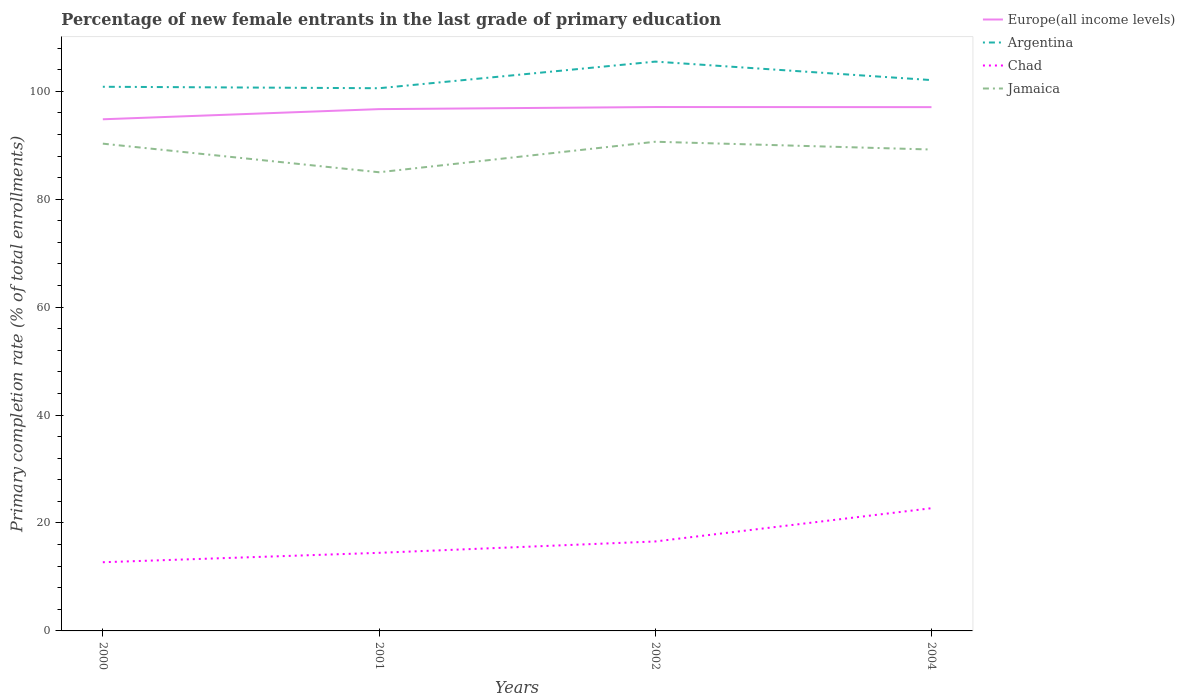How many different coloured lines are there?
Provide a short and direct response. 4. Across all years, what is the maximum percentage of new female entrants in Chad?
Your response must be concise. 12.73. In which year was the percentage of new female entrants in Europe(all income levels) maximum?
Offer a terse response. 2000. What is the total percentage of new female entrants in Argentina in the graph?
Your response must be concise. -1.51. What is the difference between the highest and the second highest percentage of new female entrants in Chad?
Give a very brief answer. 10.01. Is the percentage of new female entrants in Jamaica strictly greater than the percentage of new female entrants in Europe(all income levels) over the years?
Offer a very short reply. Yes. How many lines are there?
Provide a succinct answer. 4. What is the difference between two consecutive major ticks on the Y-axis?
Ensure brevity in your answer.  20. Are the values on the major ticks of Y-axis written in scientific E-notation?
Keep it short and to the point. No. What is the title of the graph?
Your answer should be compact. Percentage of new female entrants in the last grade of primary education. Does "Slovenia" appear as one of the legend labels in the graph?
Your response must be concise. No. What is the label or title of the Y-axis?
Give a very brief answer. Primary completion rate (% of total enrollments). What is the Primary completion rate (% of total enrollments) of Europe(all income levels) in 2000?
Provide a succinct answer. 94.81. What is the Primary completion rate (% of total enrollments) in Argentina in 2000?
Ensure brevity in your answer.  100.84. What is the Primary completion rate (% of total enrollments) in Chad in 2000?
Provide a succinct answer. 12.73. What is the Primary completion rate (% of total enrollments) of Jamaica in 2000?
Your answer should be very brief. 90.29. What is the Primary completion rate (% of total enrollments) in Europe(all income levels) in 2001?
Your answer should be very brief. 96.69. What is the Primary completion rate (% of total enrollments) in Argentina in 2001?
Provide a short and direct response. 100.56. What is the Primary completion rate (% of total enrollments) in Chad in 2001?
Your response must be concise. 14.47. What is the Primary completion rate (% of total enrollments) in Jamaica in 2001?
Offer a very short reply. 84.99. What is the Primary completion rate (% of total enrollments) of Europe(all income levels) in 2002?
Provide a succinct answer. 97.08. What is the Primary completion rate (% of total enrollments) in Argentina in 2002?
Provide a succinct answer. 105.5. What is the Primary completion rate (% of total enrollments) of Chad in 2002?
Your answer should be compact. 16.58. What is the Primary completion rate (% of total enrollments) in Jamaica in 2002?
Keep it short and to the point. 90.65. What is the Primary completion rate (% of total enrollments) of Europe(all income levels) in 2004?
Offer a terse response. 97.06. What is the Primary completion rate (% of total enrollments) of Argentina in 2004?
Keep it short and to the point. 102.07. What is the Primary completion rate (% of total enrollments) of Chad in 2004?
Make the answer very short. 22.74. What is the Primary completion rate (% of total enrollments) of Jamaica in 2004?
Ensure brevity in your answer.  89.21. Across all years, what is the maximum Primary completion rate (% of total enrollments) of Europe(all income levels)?
Keep it short and to the point. 97.08. Across all years, what is the maximum Primary completion rate (% of total enrollments) in Argentina?
Ensure brevity in your answer.  105.5. Across all years, what is the maximum Primary completion rate (% of total enrollments) in Chad?
Make the answer very short. 22.74. Across all years, what is the maximum Primary completion rate (% of total enrollments) in Jamaica?
Give a very brief answer. 90.65. Across all years, what is the minimum Primary completion rate (% of total enrollments) of Europe(all income levels)?
Offer a terse response. 94.81. Across all years, what is the minimum Primary completion rate (% of total enrollments) of Argentina?
Make the answer very short. 100.56. Across all years, what is the minimum Primary completion rate (% of total enrollments) in Chad?
Offer a terse response. 12.73. Across all years, what is the minimum Primary completion rate (% of total enrollments) in Jamaica?
Your response must be concise. 84.99. What is the total Primary completion rate (% of total enrollments) of Europe(all income levels) in the graph?
Your answer should be compact. 385.64. What is the total Primary completion rate (% of total enrollments) of Argentina in the graph?
Keep it short and to the point. 408.97. What is the total Primary completion rate (% of total enrollments) of Chad in the graph?
Provide a succinct answer. 66.52. What is the total Primary completion rate (% of total enrollments) in Jamaica in the graph?
Your answer should be compact. 355.14. What is the difference between the Primary completion rate (% of total enrollments) of Europe(all income levels) in 2000 and that in 2001?
Ensure brevity in your answer.  -1.88. What is the difference between the Primary completion rate (% of total enrollments) of Argentina in 2000 and that in 2001?
Provide a succinct answer. 0.27. What is the difference between the Primary completion rate (% of total enrollments) of Chad in 2000 and that in 2001?
Offer a very short reply. -1.74. What is the difference between the Primary completion rate (% of total enrollments) of Jamaica in 2000 and that in 2001?
Ensure brevity in your answer.  5.3. What is the difference between the Primary completion rate (% of total enrollments) of Europe(all income levels) in 2000 and that in 2002?
Ensure brevity in your answer.  -2.27. What is the difference between the Primary completion rate (% of total enrollments) in Argentina in 2000 and that in 2002?
Offer a terse response. -4.66. What is the difference between the Primary completion rate (% of total enrollments) in Chad in 2000 and that in 2002?
Provide a succinct answer. -3.85. What is the difference between the Primary completion rate (% of total enrollments) in Jamaica in 2000 and that in 2002?
Your answer should be compact. -0.36. What is the difference between the Primary completion rate (% of total enrollments) in Europe(all income levels) in 2000 and that in 2004?
Offer a terse response. -2.25. What is the difference between the Primary completion rate (% of total enrollments) of Argentina in 2000 and that in 2004?
Keep it short and to the point. -1.24. What is the difference between the Primary completion rate (% of total enrollments) in Chad in 2000 and that in 2004?
Your response must be concise. -10.01. What is the difference between the Primary completion rate (% of total enrollments) of Jamaica in 2000 and that in 2004?
Ensure brevity in your answer.  1.09. What is the difference between the Primary completion rate (% of total enrollments) of Europe(all income levels) in 2001 and that in 2002?
Provide a short and direct response. -0.39. What is the difference between the Primary completion rate (% of total enrollments) of Argentina in 2001 and that in 2002?
Your answer should be compact. -4.93. What is the difference between the Primary completion rate (% of total enrollments) of Chad in 2001 and that in 2002?
Provide a succinct answer. -2.11. What is the difference between the Primary completion rate (% of total enrollments) in Jamaica in 2001 and that in 2002?
Offer a terse response. -5.65. What is the difference between the Primary completion rate (% of total enrollments) of Europe(all income levels) in 2001 and that in 2004?
Offer a terse response. -0.37. What is the difference between the Primary completion rate (% of total enrollments) of Argentina in 2001 and that in 2004?
Provide a short and direct response. -1.51. What is the difference between the Primary completion rate (% of total enrollments) of Chad in 2001 and that in 2004?
Give a very brief answer. -8.27. What is the difference between the Primary completion rate (% of total enrollments) of Jamaica in 2001 and that in 2004?
Your response must be concise. -4.21. What is the difference between the Primary completion rate (% of total enrollments) of Europe(all income levels) in 2002 and that in 2004?
Offer a very short reply. 0.02. What is the difference between the Primary completion rate (% of total enrollments) in Argentina in 2002 and that in 2004?
Your response must be concise. 3.42. What is the difference between the Primary completion rate (% of total enrollments) in Chad in 2002 and that in 2004?
Make the answer very short. -6.16. What is the difference between the Primary completion rate (% of total enrollments) in Jamaica in 2002 and that in 2004?
Keep it short and to the point. 1.44. What is the difference between the Primary completion rate (% of total enrollments) of Europe(all income levels) in 2000 and the Primary completion rate (% of total enrollments) of Argentina in 2001?
Provide a short and direct response. -5.76. What is the difference between the Primary completion rate (% of total enrollments) of Europe(all income levels) in 2000 and the Primary completion rate (% of total enrollments) of Chad in 2001?
Give a very brief answer. 80.34. What is the difference between the Primary completion rate (% of total enrollments) in Europe(all income levels) in 2000 and the Primary completion rate (% of total enrollments) in Jamaica in 2001?
Make the answer very short. 9.82. What is the difference between the Primary completion rate (% of total enrollments) in Argentina in 2000 and the Primary completion rate (% of total enrollments) in Chad in 2001?
Your answer should be very brief. 86.37. What is the difference between the Primary completion rate (% of total enrollments) in Argentina in 2000 and the Primary completion rate (% of total enrollments) in Jamaica in 2001?
Provide a succinct answer. 15.84. What is the difference between the Primary completion rate (% of total enrollments) in Chad in 2000 and the Primary completion rate (% of total enrollments) in Jamaica in 2001?
Offer a terse response. -72.27. What is the difference between the Primary completion rate (% of total enrollments) of Europe(all income levels) in 2000 and the Primary completion rate (% of total enrollments) of Argentina in 2002?
Give a very brief answer. -10.69. What is the difference between the Primary completion rate (% of total enrollments) of Europe(all income levels) in 2000 and the Primary completion rate (% of total enrollments) of Chad in 2002?
Make the answer very short. 78.23. What is the difference between the Primary completion rate (% of total enrollments) in Europe(all income levels) in 2000 and the Primary completion rate (% of total enrollments) in Jamaica in 2002?
Your response must be concise. 4.16. What is the difference between the Primary completion rate (% of total enrollments) of Argentina in 2000 and the Primary completion rate (% of total enrollments) of Chad in 2002?
Provide a succinct answer. 84.26. What is the difference between the Primary completion rate (% of total enrollments) in Argentina in 2000 and the Primary completion rate (% of total enrollments) in Jamaica in 2002?
Your response must be concise. 10.19. What is the difference between the Primary completion rate (% of total enrollments) in Chad in 2000 and the Primary completion rate (% of total enrollments) in Jamaica in 2002?
Your response must be concise. -77.92. What is the difference between the Primary completion rate (% of total enrollments) of Europe(all income levels) in 2000 and the Primary completion rate (% of total enrollments) of Argentina in 2004?
Your answer should be very brief. -7.26. What is the difference between the Primary completion rate (% of total enrollments) of Europe(all income levels) in 2000 and the Primary completion rate (% of total enrollments) of Chad in 2004?
Make the answer very short. 72.07. What is the difference between the Primary completion rate (% of total enrollments) in Europe(all income levels) in 2000 and the Primary completion rate (% of total enrollments) in Jamaica in 2004?
Offer a very short reply. 5.6. What is the difference between the Primary completion rate (% of total enrollments) in Argentina in 2000 and the Primary completion rate (% of total enrollments) in Chad in 2004?
Make the answer very short. 78.1. What is the difference between the Primary completion rate (% of total enrollments) in Argentina in 2000 and the Primary completion rate (% of total enrollments) in Jamaica in 2004?
Your answer should be compact. 11.63. What is the difference between the Primary completion rate (% of total enrollments) of Chad in 2000 and the Primary completion rate (% of total enrollments) of Jamaica in 2004?
Make the answer very short. -76.48. What is the difference between the Primary completion rate (% of total enrollments) in Europe(all income levels) in 2001 and the Primary completion rate (% of total enrollments) in Argentina in 2002?
Ensure brevity in your answer.  -8.8. What is the difference between the Primary completion rate (% of total enrollments) in Europe(all income levels) in 2001 and the Primary completion rate (% of total enrollments) in Chad in 2002?
Make the answer very short. 80.11. What is the difference between the Primary completion rate (% of total enrollments) in Europe(all income levels) in 2001 and the Primary completion rate (% of total enrollments) in Jamaica in 2002?
Provide a short and direct response. 6.04. What is the difference between the Primary completion rate (% of total enrollments) of Argentina in 2001 and the Primary completion rate (% of total enrollments) of Chad in 2002?
Make the answer very short. 83.99. What is the difference between the Primary completion rate (% of total enrollments) of Argentina in 2001 and the Primary completion rate (% of total enrollments) of Jamaica in 2002?
Your response must be concise. 9.92. What is the difference between the Primary completion rate (% of total enrollments) in Chad in 2001 and the Primary completion rate (% of total enrollments) in Jamaica in 2002?
Provide a succinct answer. -76.18. What is the difference between the Primary completion rate (% of total enrollments) of Europe(all income levels) in 2001 and the Primary completion rate (% of total enrollments) of Argentina in 2004?
Your answer should be very brief. -5.38. What is the difference between the Primary completion rate (% of total enrollments) in Europe(all income levels) in 2001 and the Primary completion rate (% of total enrollments) in Chad in 2004?
Keep it short and to the point. 73.95. What is the difference between the Primary completion rate (% of total enrollments) in Europe(all income levels) in 2001 and the Primary completion rate (% of total enrollments) in Jamaica in 2004?
Your answer should be compact. 7.49. What is the difference between the Primary completion rate (% of total enrollments) in Argentina in 2001 and the Primary completion rate (% of total enrollments) in Chad in 2004?
Your answer should be very brief. 77.83. What is the difference between the Primary completion rate (% of total enrollments) in Argentina in 2001 and the Primary completion rate (% of total enrollments) in Jamaica in 2004?
Your answer should be very brief. 11.36. What is the difference between the Primary completion rate (% of total enrollments) of Chad in 2001 and the Primary completion rate (% of total enrollments) of Jamaica in 2004?
Ensure brevity in your answer.  -74.74. What is the difference between the Primary completion rate (% of total enrollments) of Europe(all income levels) in 2002 and the Primary completion rate (% of total enrollments) of Argentina in 2004?
Your answer should be compact. -4.99. What is the difference between the Primary completion rate (% of total enrollments) in Europe(all income levels) in 2002 and the Primary completion rate (% of total enrollments) in Chad in 2004?
Offer a terse response. 74.34. What is the difference between the Primary completion rate (% of total enrollments) in Europe(all income levels) in 2002 and the Primary completion rate (% of total enrollments) in Jamaica in 2004?
Your response must be concise. 7.87. What is the difference between the Primary completion rate (% of total enrollments) in Argentina in 2002 and the Primary completion rate (% of total enrollments) in Chad in 2004?
Make the answer very short. 82.76. What is the difference between the Primary completion rate (% of total enrollments) in Argentina in 2002 and the Primary completion rate (% of total enrollments) in Jamaica in 2004?
Keep it short and to the point. 16.29. What is the difference between the Primary completion rate (% of total enrollments) of Chad in 2002 and the Primary completion rate (% of total enrollments) of Jamaica in 2004?
Your answer should be very brief. -72.63. What is the average Primary completion rate (% of total enrollments) of Europe(all income levels) per year?
Provide a short and direct response. 96.41. What is the average Primary completion rate (% of total enrollments) of Argentina per year?
Give a very brief answer. 102.24. What is the average Primary completion rate (% of total enrollments) in Chad per year?
Your answer should be very brief. 16.63. What is the average Primary completion rate (% of total enrollments) in Jamaica per year?
Provide a short and direct response. 88.79. In the year 2000, what is the difference between the Primary completion rate (% of total enrollments) of Europe(all income levels) and Primary completion rate (% of total enrollments) of Argentina?
Make the answer very short. -6.03. In the year 2000, what is the difference between the Primary completion rate (% of total enrollments) in Europe(all income levels) and Primary completion rate (% of total enrollments) in Chad?
Provide a short and direct response. 82.08. In the year 2000, what is the difference between the Primary completion rate (% of total enrollments) of Europe(all income levels) and Primary completion rate (% of total enrollments) of Jamaica?
Make the answer very short. 4.52. In the year 2000, what is the difference between the Primary completion rate (% of total enrollments) of Argentina and Primary completion rate (% of total enrollments) of Chad?
Provide a short and direct response. 88.11. In the year 2000, what is the difference between the Primary completion rate (% of total enrollments) of Argentina and Primary completion rate (% of total enrollments) of Jamaica?
Offer a terse response. 10.54. In the year 2000, what is the difference between the Primary completion rate (% of total enrollments) of Chad and Primary completion rate (% of total enrollments) of Jamaica?
Ensure brevity in your answer.  -77.56. In the year 2001, what is the difference between the Primary completion rate (% of total enrollments) of Europe(all income levels) and Primary completion rate (% of total enrollments) of Argentina?
Ensure brevity in your answer.  -3.87. In the year 2001, what is the difference between the Primary completion rate (% of total enrollments) in Europe(all income levels) and Primary completion rate (% of total enrollments) in Chad?
Offer a terse response. 82.22. In the year 2001, what is the difference between the Primary completion rate (% of total enrollments) in Europe(all income levels) and Primary completion rate (% of total enrollments) in Jamaica?
Offer a very short reply. 11.7. In the year 2001, what is the difference between the Primary completion rate (% of total enrollments) of Argentina and Primary completion rate (% of total enrollments) of Chad?
Keep it short and to the point. 86.09. In the year 2001, what is the difference between the Primary completion rate (% of total enrollments) of Argentina and Primary completion rate (% of total enrollments) of Jamaica?
Your answer should be very brief. 15.57. In the year 2001, what is the difference between the Primary completion rate (% of total enrollments) of Chad and Primary completion rate (% of total enrollments) of Jamaica?
Offer a very short reply. -70.52. In the year 2002, what is the difference between the Primary completion rate (% of total enrollments) in Europe(all income levels) and Primary completion rate (% of total enrollments) in Argentina?
Your response must be concise. -8.42. In the year 2002, what is the difference between the Primary completion rate (% of total enrollments) in Europe(all income levels) and Primary completion rate (% of total enrollments) in Chad?
Offer a terse response. 80.5. In the year 2002, what is the difference between the Primary completion rate (% of total enrollments) in Europe(all income levels) and Primary completion rate (% of total enrollments) in Jamaica?
Ensure brevity in your answer.  6.43. In the year 2002, what is the difference between the Primary completion rate (% of total enrollments) in Argentina and Primary completion rate (% of total enrollments) in Chad?
Offer a terse response. 88.92. In the year 2002, what is the difference between the Primary completion rate (% of total enrollments) of Argentina and Primary completion rate (% of total enrollments) of Jamaica?
Give a very brief answer. 14.85. In the year 2002, what is the difference between the Primary completion rate (% of total enrollments) in Chad and Primary completion rate (% of total enrollments) in Jamaica?
Provide a short and direct response. -74.07. In the year 2004, what is the difference between the Primary completion rate (% of total enrollments) in Europe(all income levels) and Primary completion rate (% of total enrollments) in Argentina?
Give a very brief answer. -5.01. In the year 2004, what is the difference between the Primary completion rate (% of total enrollments) of Europe(all income levels) and Primary completion rate (% of total enrollments) of Chad?
Provide a short and direct response. 74.32. In the year 2004, what is the difference between the Primary completion rate (% of total enrollments) in Europe(all income levels) and Primary completion rate (% of total enrollments) in Jamaica?
Your response must be concise. 7.86. In the year 2004, what is the difference between the Primary completion rate (% of total enrollments) in Argentina and Primary completion rate (% of total enrollments) in Chad?
Provide a short and direct response. 79.33. In the year 2004, what is the difference between the Primary completion rate (% of total enrollments) in Argentina and Primary completion rate (% of total enrollments) in Jamaica?
Your answer should be compact. 12.87. In the year 2004, what is the difference between the Primary completion rate (% of total enrollments) of Chad and Primary completion rate (% of total enrollments) of Jamaica?
Your response must be concise. -66.47. What is the ratio of the Primary completion rate (% of total enrollments) of Europe(all income levels) in 2000 to that in 2001?
Your answer should be very brief. 0.98. What is the ratio of the Primary completion rate (% of total enrollments) of Chad in 2000 to that in 2001?
Offer a very short reply. 0.88. What is the ratio of the Primary completion rate (% of total enrollments) in Jamaica in 2000 to that in 2001?
Your answer should be compact. 1.06. What is the ratio of the Primary completion rate (% of total enrollments) of Europe(all income levels) in 2000 to that in 2002?
Provide a succinct answer. 0.98. What is the ratio of the Primary completion rate (% of total enrollments) of Argentina in 2000 to that in 2002?
Keep it short and to the point. 0.96. What is the ratio of the Primary completion rate (% of total enrollments) in Chad in 2000 to that in 2002?
Offer a terse response. 0.77. What is the ratio of the Primary completion rate (% of total enrollments) of Jamaica in 2000 to that in 2002?
Your answer should be very brief. 1. What is the ratio of the Primary completion rate (% of total enrollments) of Europe(all income levels) in 2000 to that in 2004?
Your answer should be very brief. 0.98. What is the ratio of the Primary completion rate (% of total enrollments) in Argentina in 2000 to that in 2004?
Keep it short and to the point. 0.99. What is the ratio of the Primary completion rate (% of total enrollments) in Chad in 2000 to that in 2004?
Offer a terse response. 0.56. What is the ratio of the Primary completion rate (% of total enrollments) in Jamaica in 2000 to that in 2004?
Your response must be concise. 1.01. What is the ratio of the Primary completion rate (% of total enrollments) in Argentina in 2001 to that in 2002?
Give a very brief answer. 0.95. What is the ratio of the Primary completion rate (% of total enrollments) in Chad in 2001 to that in 2002?
Ensure brevity in your answer.  0.87. What is the ratio of the Primary completion rate (% of total enrollments) of Jamaica in 2001 to that in 2002?
Give a very brief answer. 0.94. What is the ratio of the Primary completion rate (% of total enrollments) of Argentina in 2001 to that in 2004?
Offer a terse response. 0.99. What is the ratio of the Primary completion rate (% of total enrollments) of Chad in 2001 to that in 2004?
Your answer should be compact. 0.64. What is the ratio of the Primary completion rate (% of total enrollments) of Jamaica in 2001 to that in 2004?
Offer a very short reply. 0.95. What is the ratio of the Primary completion rate (% of total enrollments) of Argentina in 2002 to that in 2004?
Provide a short and direct response. 1.03. What is the ratio of the Primary completion rate (% of total enrollments) of Chad in 2002 to that in 2004?
Provide a succinct answer. 0.73. What is the ratio of the Primary completion rate (% of total enrollments) of Jamaica in 2002 to that in 2004?
Offer a terse response. 1.02. What is the difference between the highest and the second highest Primary completion rate (% of total enrollments) of Europe(all income levels)?
Give a very brief answer. 0.02. What is the difference between the highest and the second highest Primary completion rate (% of total enrollments) in Argentina?
Offer a terse response. 3.42. What is the difference between the highest and the second highest Primary completion rate (% of total enrollments) in Chad?
Your response must be concise. 6.16. What is the difference between the highest and the second highest Primary completion rate (% of total enrollments) of Jamaica?
Offer a very short reply. 0.36. What is the difference between the highest and the lowest Primary completion rate (% of total enrollments) of Europe(all income levels)?
Offer a terse response. 2.27. What is the difference between the highest and the lowest Primary completion rate (% of total enrollments) of Argentina?
Make the answer very short. 4.93. What is the difference between the highest and the lowest Primary completion rate (% of total enrollments) in Chad?
Ensure brevity in your answer.  10.01. What is the difference between the highest and the lowest Primary completion rate (% of total enrollments) of Jamaica?
Offer a terse response. 5.65. 